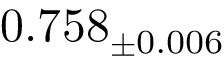<formula> <loc_0><loc_0><loc_500><loc_500>0 . 7 5 8 _ { \pm 0 . 0 0 6 }</formula> 